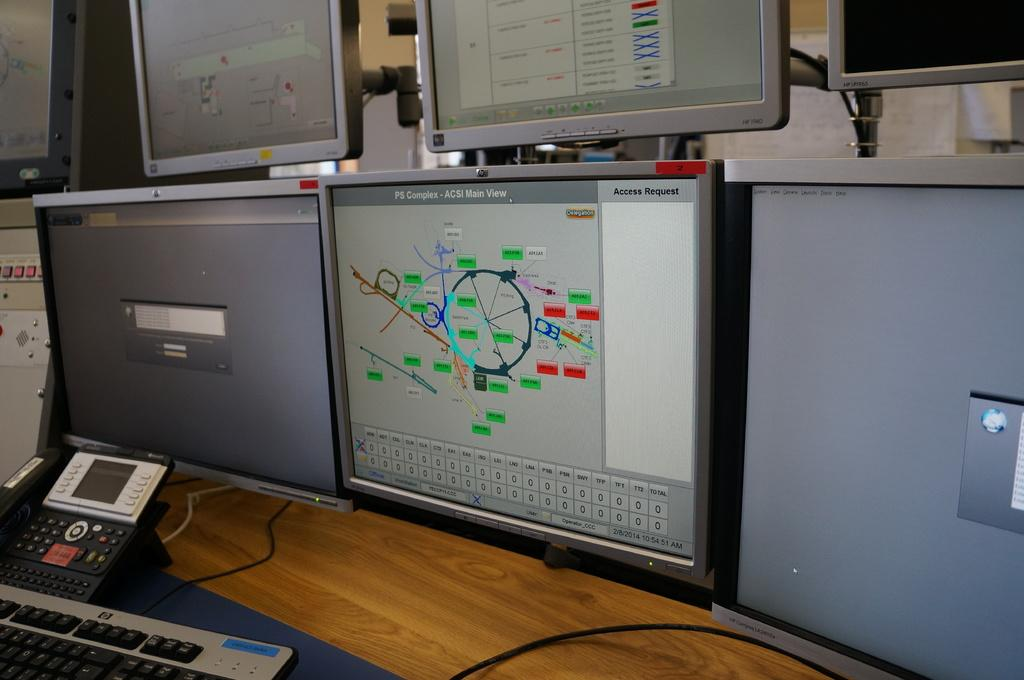<image>
Give a short and clear explanation of the subsequent image. A screen shows the main view of a PS Complex. 